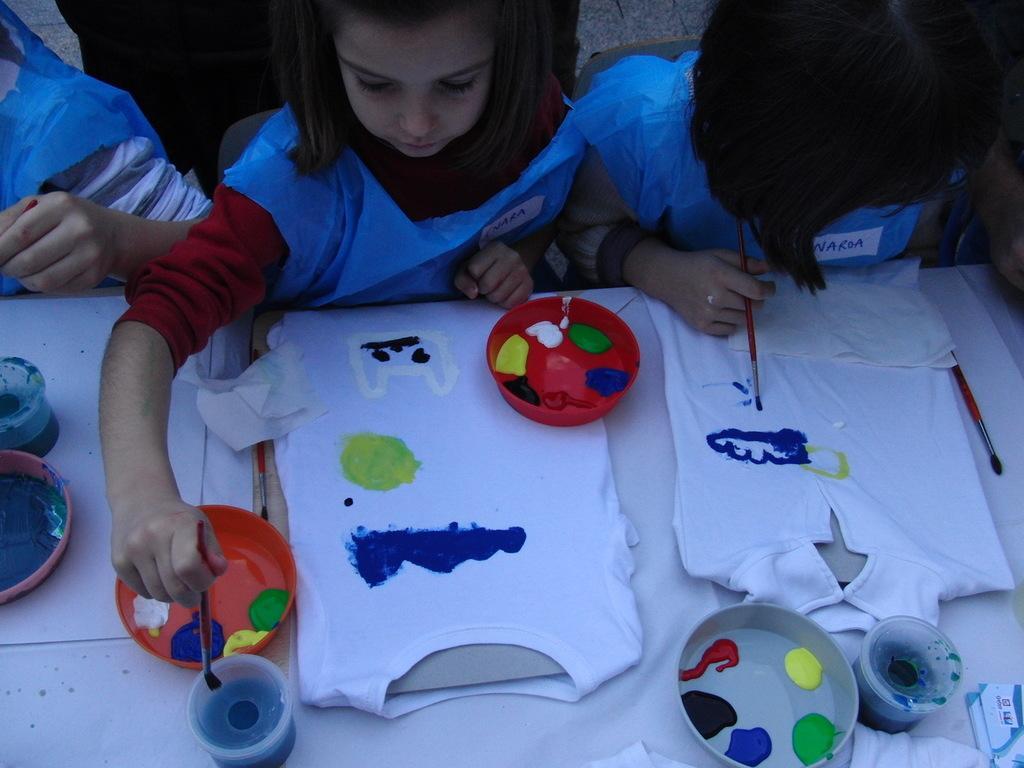Can you describe this image briefly? In this picture we can see three kids are sitting on chairs in front of a table, there are t-shirts, plastic bowls and papers present on the table, these two kids are holding paint brushes, we can see paint in these bowls. 